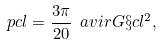Convert formula to latex. <formula><loc_0><loc_0><loc_500><loc_500>\ p c l = \frac { 3 \pi } { 2 0 } \ a v i r G \S c l ^ { 2 } ,</formula> 